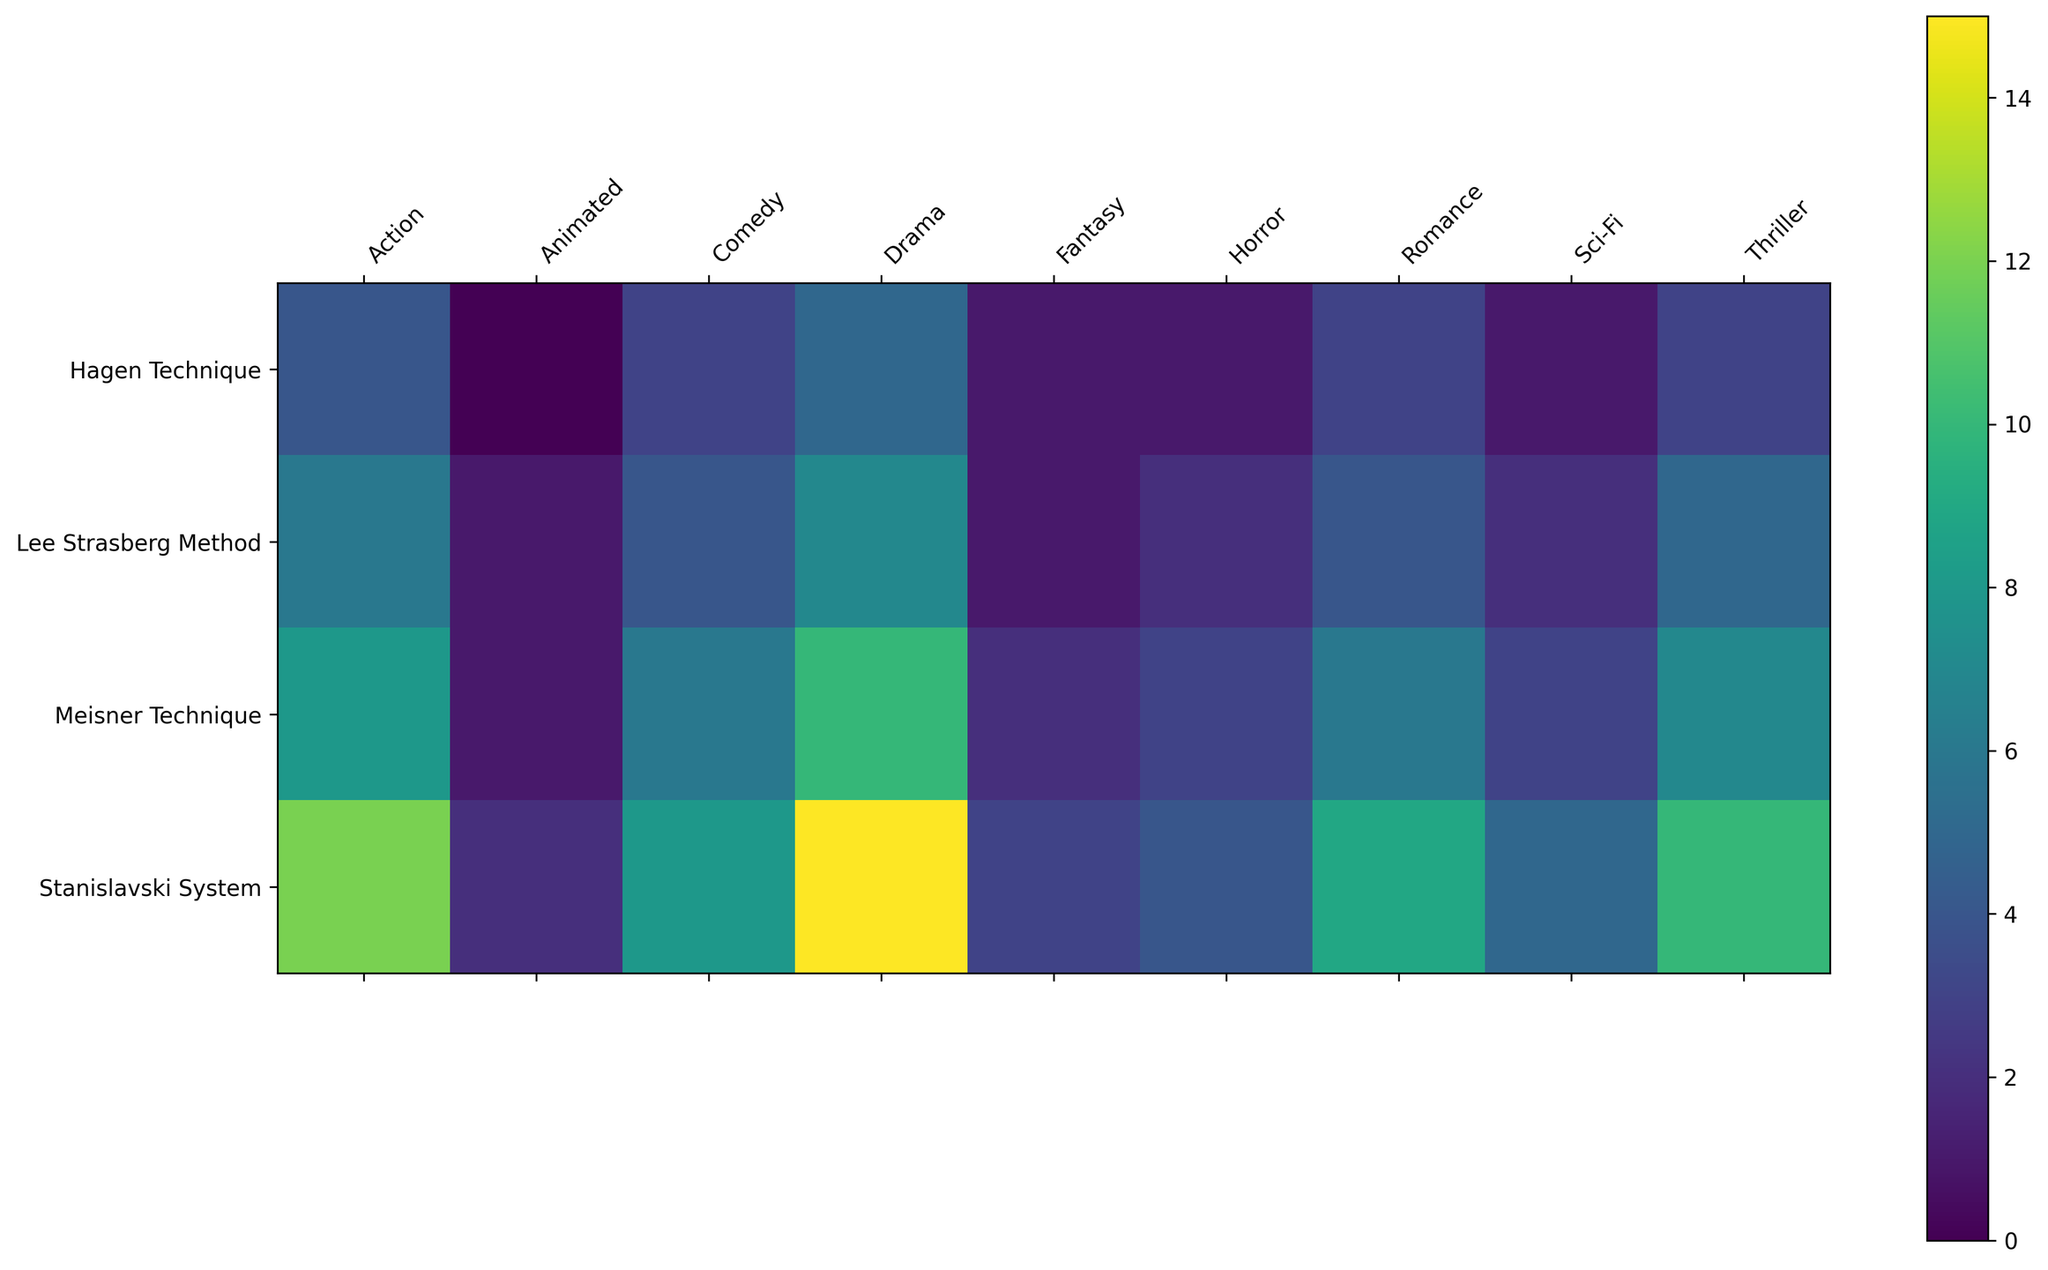Which genre has the most roles using the Stanislavski System? The Stanislavski System has the highest number of roles in the Drama genre, where it totals 15 roles.
Answer: Drama How many roles in total are there using the Meisner Technique across all genres? Summing up the roles in the Meisner Technique column: 10 (Drama) + 6 (Comedy) + 8 (Action) + 7 (Thriller) + 6 (Romance) + 3 (Horror) + 2 (Fantasy) + 3 (Sci-Fi) + 1 (Animated) equals 46.
Answer: 46 Which genre and method combination has the fewest roles? Visual inspection of the color gradient shows the darkest cell, indicating the lowest number of roles. This is the Animated genre with the Hagen Technique having 0 roles.
Answer: Animated with Hagen Technique What is the difference between the number of roles using the Stanislavski System and Lee Strasberg Method in the Action genre? In the Action genre, the Stanislavski System has 12 roles and the Lee Strasberg Method has 6 roles. The difference is 12 - 6 = 6 roles.
Answer: 6 Which method is most frequently used in the Horror genre? The Stanislavski System is the most frequently used method in the Horror genre, with 4 roles.
Answer: Stanislavski System Compare the Drama genre and the Animated genre; which has the highest variation in the number of roles between different methods? For Drama: Stanislavski System (15), Meisner Technique (10), Lee Strasberg Method (7), Hagen Technique (5) - Range is 15 - 5 = 10 roles. For Animated: Stanislavski System (2), Meisner Technique (1), Lee Strasberg Method (1), Hagen Technique (0) - Range is 2 - 0 = 2 roles. The highest variation is in the Drama genre.
Answer: Drama Is there a method that never reached more than 5 roles in any genre? The Hagen Technique does not exceed 5 roles in any genre; it reaches a maximum of 5 roles in the Drama genre.
Answer: Hagen Technique What is the total number of roles for all genres combined when using the Lee Strasberg Method? Summing the roles in the Lee Strasberg Method row: 7 (Drama) + 4 (Comedy) + 6 (Action) + 5 (Thriller) + 4 (Romance) + 2 (Horror) + 1 (Fantasy) + 2 (Sci-Fi) + 1 (Animated) equals 32.
Answer: 32 